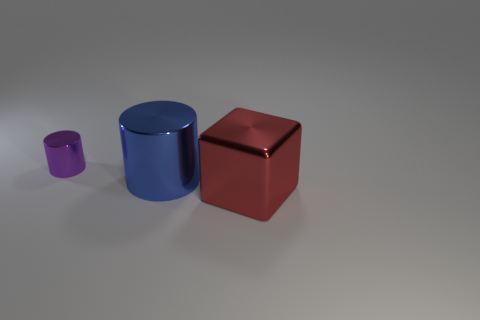Add 3 metallic cubes. How many objects exist? 6 Subtract all cylinders. How many objects are left? 1 Subtract all cubes. Subtract all small purple objects. How many objects are left? 1 Add 1 purple objects. How many purple objects are left? 2 Add 3 big brown shiny objects. How many big brown shiny objects exist? 3 Subtract 0 blue balls. How many objects are left? 3 Subtract all cyan cylinders. Subtract all cyan cubes. How many cylinders are left? 2 